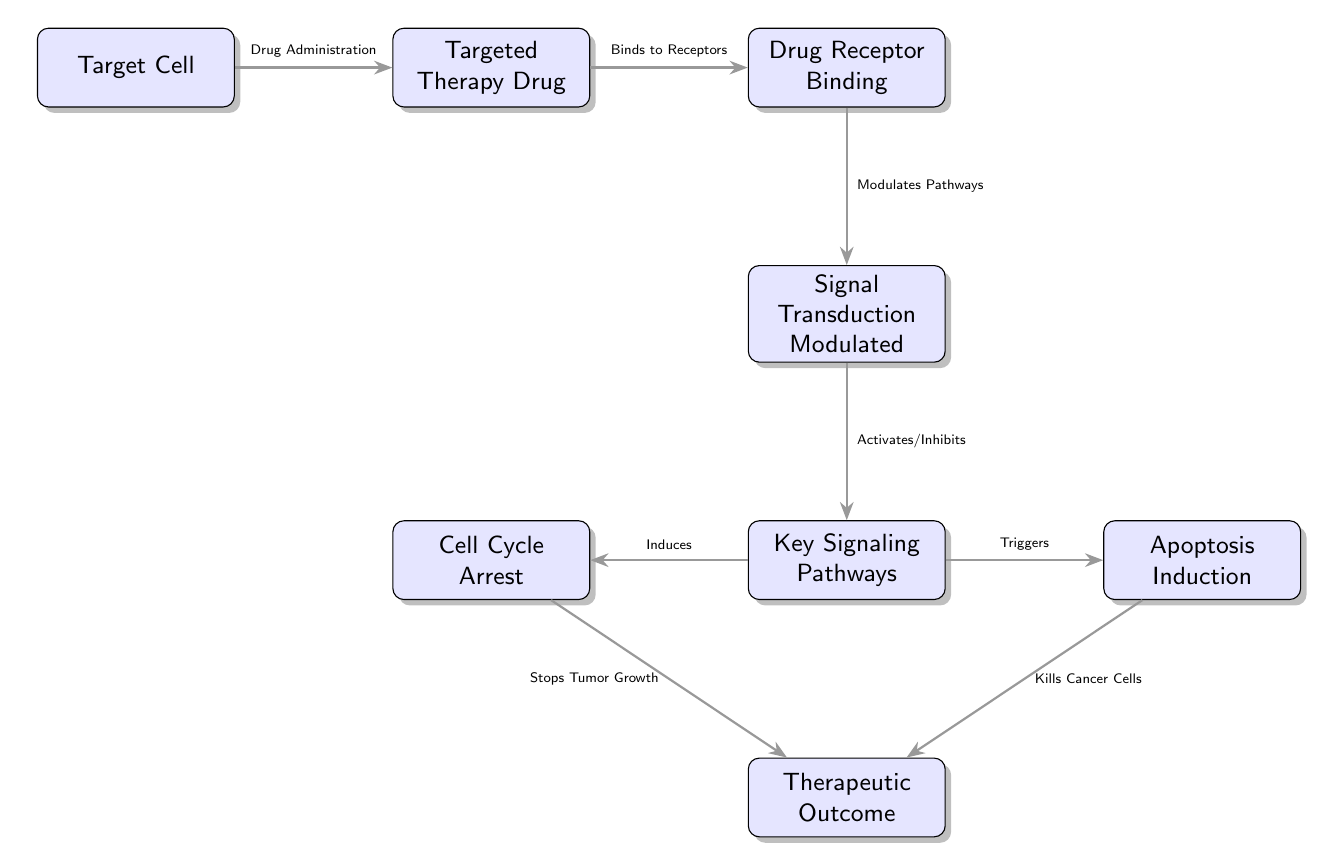What is the first node in the diagram? The first node in the diagram is labeled "Target Cell," indicating the initial point of focus in the mechanism of action pathway for targeted therapy.
Answer: Target Cell How many nodes are present in the diagram? By counting each labeled block in the diagram, we find there are eight distinct nodes, which represent different components of the mechanism of action pathway.
Answer: 8 What action occurs after "Drug Administration"? After "Drug Administration," the next step is "Binds to Receptors," indicating the subsequent action taken by the targeted therapy drug in the pathway.
Answer: Binds to Receptors What is the relationship between "Key Signaling Pathways" and "Cell Cycle Arrest"? "Key Signaling Pathways" induces "Cell Cycle Arrest," showing a direct effect of the signaling pathway on halting the cell cycle in the target cell.
Answer: Induces Which nodes are connected to "Therapeutic Outcome"? "Cell Cycle Arrest" and "Apoptosis Induction" both flow into "Therapeutic Outcome," indicating that both processes contribute to the overall therapeutic effect.
Answer: Cell Cycle Arrest, Apoptosis Induction What is the last action in the pathway? The last action in the mechanism is "Therapeutic Outcome," which summarizes the end result of the entire pathway after all prior actions have taken place.
Answer: Therapeutic Outcome Which node follows "Modulates Pathways"? The node that follows "Modulates Pathways" is "Key Signaling Pathways," indicating that pathway modulation leads directly to the activation or inhibition of these key pathways.
Answer: Key Signaling Pathways What triggers "Apoptosis Induction"? "Key Signaling Pathways" triggers "Apoptosis Induction," showing that the activation or inhibition of these pathways can lead to the programmed cell death of cancer cells.
Answer: Triggers 